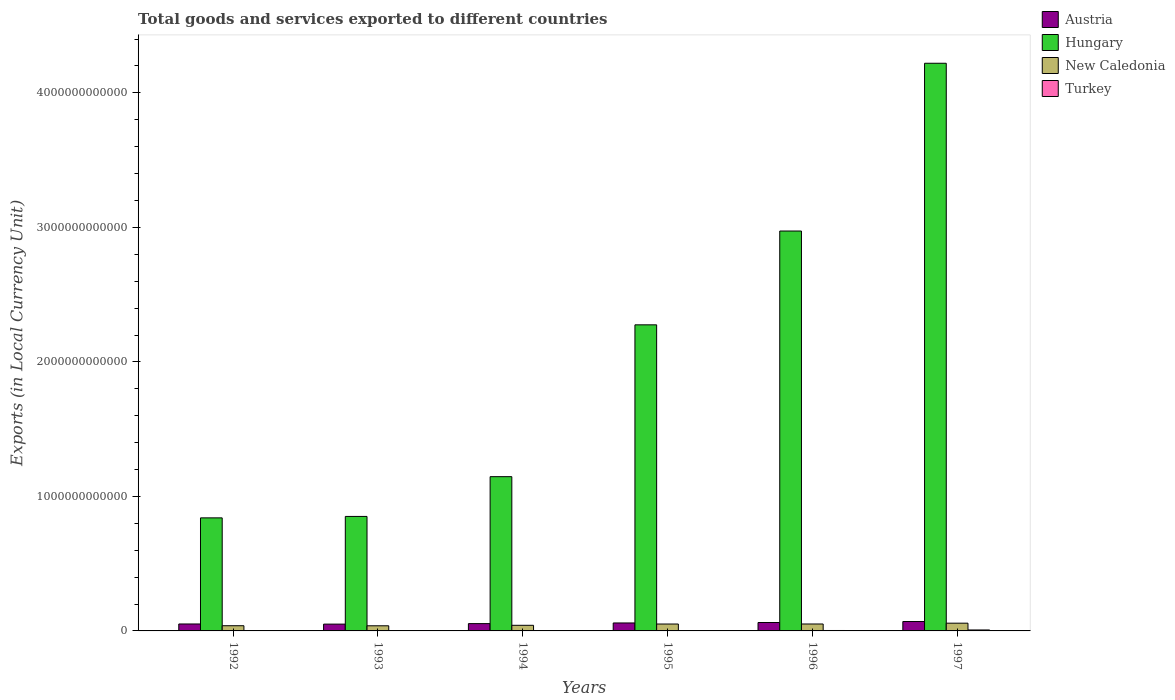How many groups of bars are there?
Give a very brief answer. 6. Are the number of bars per tick equal to the number of legend labels?
Provide a short and direct response. Yes. How many bars are there on the 1st tick from the right?
Your response must be concise. 4. In how many cases, is the number of bars for a given year not equal to the number of legend labels?
Give a very brief answer. 0. What is the Amount of goods and services exports in Austria in 1994?
Your answer should be compact. 5.43e+1. Across all years, what is the maximum Amount of goods and services exports in Hungary?
Your answer should be very brief. 4.22e+12. Across all years, what is the minimum Amount of goods and services exports in Hungary?
Offer a terse response. 8.41e+11. In which year was the Amount of goods and services exports in Turkey maximum?
Give a very brief answer. 1997. What is the total Amount of goods and services exports in Turkey in the graph?
Make the answer very short. 1.31e+1. What is the difference between the Amount of goods and services exports in New Caledonia in 1993 and that in 1994?
Make the answer very short. -3.61e+09. What is the difference between the Amount of goods and services exports in Turkey in 1993 and the Amount of goods and services exports in New Caledonia in 1995?
Give a very brief answer. -5.10e+1. What is the average Amount of goods and services exports in Turkey per year?
Offer a very short reply. 2.18e+09. In the year 1994, what is the difference between the Amount of goods and services exports in Austria and Amount of goods and services exports in Hungary?
Keep it short and to the point. -1.09e+12. What is the ratio of the Amount of goods and services exports in Turkey in 1993 to that in 1996?
Provide a succinct answer. 0.09. Is the Amount of goods and services exports in Austria in 1992 less than that in 1996?
Your answer should be compact. Yes. What is the difference between the highest and the second highest Amount of goods and services exports in New Caledonia?
Make the answer very short. 6.12e+09. What is the difference between the highest and the lowest Amount of goods and services exports in New Caledonia?
Provide a succinct answer. 1.95e+1. Is it the case that in every year, the sum of the Amount of goods and services exports in New Caledonia and Amount of goods and services exports in Turkey is greater than the sum of Amount of goods and services exports in Austria and Amount of goods and services exports in Hungary?
Offer a terse response. No. What does the 1st bar from the left in 1995 represents?
Provide a succinct answer. Austria. What does the 4th bar from the right in 1994 represents?
Make the answer very short. Austria. Is it the case that in every year, the sum of the Amount of goods and services exports in Hungary and Amount of goods and services exports in New Caledonia is greater than the Amount of goods and services exports in Turkey?
Give a very brief answer. Yes. How many bars are there?
Your answer should be compact. 24. How many years are there in the graph?
Give a very brief answer. 6. What is the difference between two consecutive major ticks on the Y-axis?
Your answer should be compact. 1.00e+12. Are the values on the major ticks of Y-axis written in scientific E-notation?
Give a very brief answer. No. Where does the legend appear in the graph?
Ensure brevity in your answer.  Top right. How many legend labels are there?
Your answer should be compact. 4. How are the legend labels stacked?
Provide a short and direct response. Vertical. What is the title of the graph?
Give a very brief answer. Total goods and services exported to different countries. Does "Romania" appear as one of the legend labels in the graph?
Provide a short and direct response. No. What is the label or title of the Y-axis?
Ensure brevity in your answer.  Exports (in Local Currency Unit). What is the Exports (in Local Currency Unit) in Austria in 1992?
Your answer should be compact. 5.17e+1. What is the Exports (in Local Currency Unit) of Hungary in 1992?
Provide a short and direct response. 8.41e+11. What is the Exports (in Local Currency Unit) of New Caledonia in 1992?
Offer a terse response. 3.86e+1. What is the Exports (in Local Currency Unit) in Turkey in 1992?
Your answer should be compact. 1.57e+08. What is the Exports (in Local Currency Unit) in Austria in 1993?
Provide a short and direct response. 5.06e+1. What is the Exports (in Local Currency Unit) in Hungary in 1993?
Offer a very short reply. 8.51e+11. What is the Exports (in Local Currency Unit) in New Caledonia in 1993?
Give a very brief answer. 3.81e+1. What is the Exports (in Local Currency Unit) in Turkey in 1993?
Provide a short and direct response. 2.71e+08. What is the Exports (in Local Currency Unit) in Austria in 1994?
Your answer should be compact. 5.43e+1. What is the Exports (in Local Currency Unit) of Hungary in 1994?
Offer a terse response. 1.15e+12. What is the Exports (in Local Currency Unit) in New Caledonia in 1994?
Give a very brief answer. 4.17e+1. What is the Exports (in Local Currency Unit) of Turkey in 1994?
Ensure brevity in your answer.  8.26e+08. What is the Exports (in Local Currency Unit) in Austria in 1995?
Ensure brevity in your answer.  5.92e+1. What is the Exports (in Local Currency Unit) in Hungary in 1995?
Provide a succinct answer. 2.28e+12. What is the Exports (in Local Currency Unit) in New Caledonia in 1995?
Provide a short and direct response. 5.13e+1. What is the Exports (in Local Currency Unit) of Turkey in 1995?
Make the answer very short. 1.54e+09. What is the Exports (in Local Currency Unit) of Austria in 1996?
Offer a very short reply. 6.25e+1. What is the Exports (in Local Currency Unit) of Hungary in 1996?
Provide a succinct answer. 2.97e+12. What is the Exports (in Local Currency Unit) of New Caledonia in 1996?
Your answer should be compact. 5.15e+1. What is the Exports (in Local Currency Unit) in Turkey in 1996?
Make the answer very short. 3.18e+09. What is the Exports (in Local Currency Unit) in Austria in 1997?
Provide a succinct answer. 6.99e+1. What is the Exports (in Local Currency Unit) of Hungary in 1997?
Make the answer very short. 4.22e+12. What is the Exports (in Local Currency Unit) of New Caledonia in 1997?
Offer a very short reply. 5.76e+1. What is the Exports (in Local Currency Unit) in Turkey in 1997?
Offer a terse response. 7.09e+09. Across all years, what is the maximum Exports (in Local Currency Unit) in Austria?
Offer a very short reply. 6.99e+1. Across all years, what is the maximum Exports (in Local Currency Unit) in Hungary?
Ensure brevity in your answer.  4.22e+12. Across all years, what is the maximum Exports (in Local Currency Unit) of New Caledonia?
Make the answer very short. 5.76e+1. Across all years, what is the maximum Exports (in Local Currency Unit) in Turkey?
Make the answer very short. 7.09e+09. Across all years, what is the minimum Exports (in Local Currency Unit) in Austria?
Your answer should be very brief. 5.06e+1. Across all years, what is the minimum Exports (in Local Currency Unit) of Hungary?
Make the answer very short. 8.41e+11. Across all years, what is the minimum Exports (in Local Currency Unit) in New Caledonia?
Provide a succinct answer. 3.81e+1. Across all years, what is the minimum Exports (in Local Currency Unit) of Turkey?
Offer a terse response. 1.57e+08. What is the total Exports (in Local Currency Unit) of Austria in the graph?
Give a very brief answer. 3.48e+11. What is the total Exports (in Local Currency Unit) of Hungary in the graph?
Offer a terse response. 1.23e+13. What is the total Exports (in Local Currency Unit) of New Caledonia in the graph?
Your response must be concise. 2.79e+11. What is the total Exports (in Local Currency Unit) of Turkey in the graph?
Your response must be concise. 1.31e+1. What is the difference between the Exports (in Local Currency Unit) in Austria in 1992 and that in 1993?
Your response must be concise. 1.02e+09. What is the difference between the Exports (in Local Currency Unit) in Hungary in 1992 and that in 1993?
Your response must be concise. -1.06e+1. What is the difference between the Exports (in Local Currency Unit) of New Caledonia in 1992 and that in 1993?
Your answer should be compact. 4.84e+08. What is the difference between the Exports (in Local Currency Unit) in Turkey in 1992 and that in 1993?
Your response must be concise. -1.14e+08. What is the difference between the Exports (in Local Currency Unit) of Austria in 1992 and that in 1994?
Your response must be concise. -2.68e+09. What is the difference between the Exports (in Local Currency Unit) of Hungary in 1992 and that in 1994?
Provide a short and direct response. -3.06e+11. What is the difference between the Exports (in Local Currency Unit) of New Caledonia in 1992 and that in 1994?
Your answer should be very brief. -3.12e+09. What is the difference between the Exports (in Local Currency Unit) of Turkey in 1992 and that in 1994?
Provide a succinct answer. -6.69e+08. What is the difference between the Exports (in Local Currency Unit) in Austria in 1992 and that in 1995?
Keep it short and to the point. -7.57e+09. What is the difference between the Exports (in Local Currency Unit) of Hungary in 1992 and that in 1995?
Your response must be concise. -1.44e+12. What is the difference between the Exports (in Local Currency Unit) in New Caledonia in 1992 and that in 1995?
Provide a succinct answer. -1.27e+1. What is the difference between the Exports (in Local Currency Unit) of Turkey in 1992 and that in 1995?
Make the answer very short. -1.39e+09. What is the difference between the Exports (in Local Currency Unit) of Austria in 1992 and that in 1996?
Your answer should be compact. -1.09e+1. What is the difference between the Exports (in Local Currency Unit) in Hungary in 1992 and that in 1996?
Provide a short and direct response. -2.13e+12. What is the difference between the Exports (in Local Currency Unit) in New Caledonia in 1992 and that in 1996?
Your response must be concise. -1.29e+1. What is the difference between the Exports (in Local Currency Unit) in Turkey in 1992 and that in 1996?
Make the answer very short. -3.02e+09. What is the difference between the Exports (in Local Currency Unit) in Austria in 1992 and that in 1997?
Ensure brevity in your answer.  -1.82e+1. What is the difference between the Exports (in Local Currency Unit) in Hungary in 1992 and that in 1997?
Ensure brevity in your answer.  -3.38e+12. What is the difference between the Exports (in Local Currency Unit) of New Caledonia in 1992 and that in 1997?
Your response must be concise. -1.90e+1. What is the difference between the Exports (in Local Currency Unit) in Turkey in 1992 and that in 1997?
Keep it short and to the point. -6.93e+09. What is the difference between the Exports (in Local Currency Unit) in Austria in 1993 and that in 1994?
Your answer should be very brief. -3.70e+09. What is the difference between the Exports (in Local Currency Unit) of Hungary in 1993 and that in 1994?
Your response must be concise. -2.96e+11. What is the difference between the Exports (in Local Currency Unit) of New Caledonia in 1993 and that in 1994?
Your response must be concise. -3.61e+09. What is the difference between the Exports (in Local Currency Unit) in Turkey in 1993 and that in 1994?
Provide a succinct answer. -5.55e+08. What is the difference between the Exports (in Local Currency Unit) of Austria in 1993 and that in 1995?
Ensure brevity in your answer.  -8.59e+09. What is the difference between the Exports (in Local Currency Unit) of Hungary in 1993 and that in 1995?
Your answer should be compact. -1.42e+12. What is the difference between the Exports (in Local Currency Unit) in New Caledonia in 1993 and that in 1995?
Give a very brief answer. -1.31e+1. What is the difference between the Exports (in Local Currency Unit) of Turkey in 1993 and that in 1995?
Offer a terse response. -1.27e+09. What is the difference between the Exports (in Local Currency Unit) in Austria in 1993 and that in 1996?
Keep it short and to the point. -1.19e+1. What is the difference between the Exports (in Local Currency Unit) in Hungary in 1993 and that in 1996?
Keep it short and to the point. -2.12e+12. What is the difference between the Exports (in Local Currency Unit) of New Caledonia in 1993 and that in 1996?
Your response must be concise. -1.34e+1. What is the difference between the Exports (in Local Currency Unit) in Turkey in 1993 and that in 1996?
Offer a very short reply. -2.91e+09. What is the difference between the Exports (in Local Currency Unit) of Austria in 1993 and that in 1997?
Offer a terse response. -1.92e+1. What is the difference between the Exports (in Local Currency Unit) in Hungary in 1993 and that in 1997?
Offer a very short reply. -3.37e+12. What is the difference between the Exports (in Local Currency Unit) in New Caledonia in 1993 and that in 1997?
Keep it short and to the point. -1.95e+1. What is the difference between the Exports (in Local Currency Unit) of Turkey in 1993 and that in 1997?
Your answer should be very brief. -6.82e+09. What is the difference between the Exports (in Local Currency Unit) in Austria in 1994 and that in 1995?
Give a very brief answer. -4.89e+09. What is the difference between the Exports (in Local Currency Unit) in Hungary in 1994 and that in 1995?
Your answer should be very brief. -1.13e+12. What is the difference between the Exports (in Local Currency Unit) in New Caledonia in 1994 and that in 1995?
Give a very brief answer. -9.54e+09. What is the difference between the Exports (in Local Currency Unit) in Turkey in 1994 and that in 1995?
Ensure brevity in your answer.  -7.18e+08. What is the difference between the Exports (in Local Currency Unit) in Austria in 1994 and that in 1996?
Ensure brevity in your answer.  -8.19e+09. What is the difference between the Exports (in Local Currency Unit) of Hungary in 1994 and that in 1996?
Keep it short and to the point. -1.83e+12. What is the difference between the Exports (in Local Currency Unit) in New Caledonia in 1994 and that in 1996?
Your answer should be very brief. -9.78e+09. What is the difference between the Exports (in Local Currency Unit) of Turkey in 1994 and that in 1996?
Keep it short and to the point. -2.36e+09. What is the difference between the Exports (in Local Currency Unit) of Austria in 1994 and that in 1997?
Provide a short and direct response. -1.55e+1. What is the difference between the Exports (in Local Currency Unit) of Hungary in 1994 and that in 1997?
Give a very brief answer. -3.07e+12. What is the difference between the Exports (in Local Currency Unit) in New Caledonia in 1994 and that in 1997?
Make the answer very short. -1.59e+1. What is the difference between the Exports (in Local Currency Unit) of Turkey in 1994 and that in 1997?
Provide a succinct answer. -6.26e+09. What is the difference between the Exports (in Local Currency Unit) in Austria in 1995 and that in 1996?
Your answer should be compact. -3.30e+09. What is the difference between the Exports (in Local Currency Unit) of Hungary in 1995 and that in 1996?
Give a very brief answer. -6.97e+11. What is the difference between the Exports (in Local Currency Unit) of New Caledonia in 1995 and that in 1996?
Provide a short and direct response. -2.33e+08. What is the difference between the Exports (in Local Currency Unit) in Turkey in 1995 and that in 1996?
Offer a terse response. -1.64e+09. What is the difference between the Exports (in Local Currency Unit) in Austria in 1995 and that in 1997?
Give a very brief answer. -1.07e+1. What is the difference between the Exports (in Local Currency Unit) in Hungary in 1995 and that in 1997?
Keep it short and to the point. -1.94e+12. What is the difference between the Exports (in Local Currency Unit) in New Caledonia in 1995 and that in 1997?
Your response must be concise. -6.35e+09. What is the difference between the Exports (in Local Currency Unit) of Turkey in 1995 and that in 1997?
Ensure brevity in your answer.  -5.54e+09. What is the difference between the Exports (in Local Currency Unit) of Austria in 1996 and that in 1997?
Your answer should be very brief. -7.36e+09. What is the difference between the Exports (in Local Currency Unit) in Hungary in 1996 and that in 1997?
Offer a terse response. -1.25e+12. What is the difference between the Exports (in Local Currency Unit) of New Caledonia in 1996 and that in 1997?
Keep it short and to the point. -6.12e+09. What is the difference between the Exports (in Local Currency Unit) in Turkey in 1996 and that in 1997?
Provide a succinct answer. -3.91e+09. What is the difference between the Exports (in Local Currency Unit) in Austria in 1992 and the Exports (in Local Currency Unit) in Hungary in 1993?
Give a very brief answer. -8.00e+11. What is the difference between the Exports (in Local Currency Unit) in Austria in 1992 and the Exports (in Local Currency Unit) in New Caledonia in 1993?
Give a very brief answer. 1.36e+1. What is the difference between the Exports (in Local Currency Unit) in Austria in 1992 and the Exports (in Local Currency Unit) in Turkey in 1993?
Provide a succinct answer. 5.14e+1. What is the difference between the Exports (in Local Currency Unit) of Hungary in 1992 and the Exports (in Local Currency Unit) of New Caledonia in 1993?
Offer a very short reply. 8.02e+11. What is the difference between the Exports (in Local Currency Unit) in Hungary in 1992 and the Exports (in Local Currency Unit) in Turkey in 1993?
Give a very brief answer. 8.40e+11. What is the difference between the Exports (in Local Currency Unit) of New Caledonia in 1992 and the Exports (in Local Currency Unit) of Turkey in 1993?
Make the answer very short. 3.83e+1. What is the difference between the Exports (in Local Currency Unit) of Austria in 1992 and the Exports (in Local Currency Unit) of Hungary in 1994?
Offer a terse response. -1.10e+12. What is the difference between the Exports (in Local Currency Unit) in Austria in 1992 and the Exports (in Local Currency Unit) in New Caledonia in 1994?
Ensure brevity in your answer.  9.95e+09. What is the difference between the Exports (in Local Currency Unit) in Austria in 1992 and the Exports (in Local Currency Unit) in Turkey in 1994?
Offer a very short reply. 5.08e+1. What is the difference between the Exports (in Local Currency Unit) of Hungary in 1992 and the Exports (in Local Currency Unit) of New Caledonia in 1994?
Your response must be concise. 7.99e+11. What is the difference between the Exports (in Local Currency Unit) in Hungary in 1992 and the Exports (in Local Currency Unit) in Turkey in 1994?
Give a very brief answer. 8.40e+11. What is the difference between the Exports (in Local Currency Unit) in New Caledonia in 1992 and the Exports (in Local Currency Unit) in Turkey in 1994?
Ensure brevity in your answer.  3.78e+1. What is the difference between the Exports (in Local Currency Unit) in Austria in 1992 and the Exports (in Local Currency Unit) in Hungary in 1995?
Give a very brief answer. -2.22e+12. What is the difference between the Exports (in Local Currency Unit) of Austria in 1992 and the Exports (in Local Currency Unit) of New Caledonia in 1995?
Keep it short and to the point. 4.01e+08. What is the difference between the Exports (in Local Currency Unit) of Austria in 1992 and the Exports (in Local Currency Unit) of Turkey in 1995?
Offer a very short reply. 5.01e+1. What is the difference between the Exports (in Local Currency Unit) of Hungary in 1992 and the Exports (in Local Currency Unit) of New Caledonia in 1995?
Provide a short and direct response. 7.89e+11. What is the difference between the Exports (in Local Currency Unit) in Hungary in 1992 and the Exports (in Local Currency Unit) in Turkey in 1995?
Provide a succinct answer. 8.39e+11. What is the difference between the Exports (in Local Currency Unit) in New Caledonia in 1992 and the Exports (in Local Currency Unit) in Turkey in 1995?
Give a very brief answer. 3.70e+1. What is the difference between the Exports (in Local Currency Unit) in Austria in 1992 and the Exports (in Local Currency Unit) in Hungary in 1996?
Offer a very short reply. -2.92e+12. What is the difference between the Exports (in Local Currency Unit) in Austria in 1992 and the Exports (in Local Currency Unit) in New Caledonia in 1996?
Your answer should be very brief. 1.68e+08. What is the difference between the Exports (in Local Currency Unit) of Austria in 1992 and the Exports (in Local Currency Unit) of Turkey in 1996?
Your response must be concise. 4.85e+1. What is the difference between the Exports (in Local Currency Unit) in Hungary in 1992 and the Exports (in Local Currency Unit) in New Caledonia in 1996?
Your answer should be very brief. 7.89e+11. What is the difference between the Exports (in Local Currency Unit) in Hungary in 1992 and the Exports (in Local Currency Unit) in Turkey in 1996?
Provide a short and direct response. 8.37e+11. What is the difference between the Exports (in Local Currency Unit) of New Caledonia in 1992 and the Exports (in Local Currency Unit) of Turkey in 1996?
Keep it short and to the point. 3.54e+1. What is the difference between the Exports (in Local Currency Unit) of Austria in 1992 and the Exports (in Local Currency Unit) of Hungary in 1997?
Offer a terse response. -4.17e+12. What is the difference between the Exports (in Local Currency Unit) in Austria in 1992 and the Exports (in Local Currency Unit) in New Caledonia in 1997?
Your answer should be very brief. -5.95e+09. What is the difference between the Exports (in Local Currency Unit) in Austria in 1992 and the Exports (in Local Currency Unit) in Turkey in 1997?
Offer a very short reply. 4.46e+1. What is the difference between the Exports (in Local Currency Unit) in Hungary in 1992 and the Exports (in Local Currency Unit) in New Caledonia in 1997?
Provide a short and direct response. 7.83e+11. What is the difference between the Exports (in Local Currency Unit) of Hungary in 1992 and the Exports (in Local Currency Unit) of Turkey in 1997?
Provide a short and direct response. 8.33e+11. What is the difference between the Exports (in Local Currency Unit) of New Caledonia in 1992 and the Exports (in Local Currency Unit) of Turkey in 1997?
Give a very brief answer. 3.15e+1. What is the difference between the Exports (in Local Currency Unit) of Austria in 1993 and the Exports (in Local Currency Unit) of Hungary in 1994?
Provide a short and direct response. -1.10e+12. What is the difference between the Exports (in Local Currency Unit) of Austria in 1993 and the Exports (in Local Currency Unit) of New Caledonia in 1994?
Ensure brevity in your answer.  8.93e+09. What is the difference between the Exports (in Local Currency Unit) in Austria in 1993 and the Exports (in Local Currency Unit) in Turkey in 1994?
Your answer should be compact. 4.98e+1. What is the difference between the Exports (in Local Currency Unit) of Hungary in 1993 and the Exports (in Local Currency Unit) of New Caledonia in 1994?
Ensure brevity in your answer.  8.09e+11. What is the difference between the Exports (in Local Currency Unit) in Hungary in 1993 and the Exports (in Local Currency Unit) in Turkey in 1994?
Make the answer very short. 8.50e+11. What is the difference between the Exports (in Local Currency Unit) in New Caledonia in 1993 and the Exports (in Local Currency Unit) in Turkey in 1994?
Your answer should be compact. 3.73e+1. What is the difference between the Exports (in Local Currency Unit) in Austria in 1993 and the Exports (in Local Currency Unit) in Hungary in 1995?
Your answer should be very brief. -2.23e+12. What is the difference between the Exports (in Local Currency Unit) in Austria in 1993 and the Exports (in Local Currency Unit) in New Caledonia in 1995?
Your answer should be compact. -6.17e+08. What is the difference between the Exports (in Local Currency Unit) in Austria in 1993 and the Exports (in Local Currency Unit) in Turkey in 1995?
Your answer should be compact. 4.91e+1. What is the difference between the Exports (in Local Currency Unit) in Hungary in 1993 and the Exports (in Local Currency Unit) in New Caledonia in 1995?
Ensure brevity in your answer.  8.00e+11. What is the difference between the Exports (in Local Currency Unit) of Hungary in 1993 and the Exports (in Local Currency Unit) of Turkey in 1995?
Offer a very short reply. 8.50e+11. What is the difference between the Exports (in Local Currency Unit) in New Caledonia in 1993 and the Exports (in Local Currency Unit) in Turkey in 1995?
Ensure brevity in your answer.  3.66e+1. What is the difference between the Exports (in Local Currency Unit) in Austria in 1993 and the Exports (in Local Currency Unit) in Hungary in 1996?
Your answer should be very brief. -2.92e+12. What is the difference between the Exports (in Local Currency Unit) of Austria in 1993 and the Exports (in Local Currency Unit) of New Caledonia in 1996?
Ensure brevity in your answer.  -8.50e+08. What is the difference between the Exports (in Local Currency Unit) in Austria in 1993 and the Exports (in Local Currency Unit) in Turkey in 1996?
Offer a very short reply. 4.75e+1. What is the difference between the Exports (in Local Currency Unit) in Hungary in 1993 and the Exports (in Local Currency Unit) in New Caledonia in 1996?
Make the answer very short. 8.00e+11. What is the difference between the Exports (in Local Currency Unit) of Hungary in 1993 and the Exports (in Local Currency Unit) of Turkey in 1996?
Your answer should be very brief. 8.48e+11. What is the difference between the Exports (in Local Currency Unit) of New Caledonia in 1993 and the Exports (in Local Currency Unit) of Turkey in 1996?
Ensure brevity in your answer.  3.49e+1. What is the difference between the Exports (in Local Currency Unit) in Austria in 1993 and the Exports (in Local Currency Unit) in Hungary in 1997?
Your answer should be compact. -4.17e+12. What is the difference between the Exports (in Local Currency Unit) of Austria in 1993 and the Exports (in Local Currency Unit) of New Caledonia in 1997?
Your response must be concise. -6.97e+09. What is the difference between the Exports (in Local Currency Unit) of Austria in 1993 and the Exports (in Local Currency Unit) of Turkey in 1997?
Keep it short and to the point. 4.35e+1. What is the difference between the Exports (in Local Currency Unit) in Hungary in 1993 and the Exports (in Local Currency Unit) in New Caledonia in 1997?
Offer a terse response. 7.94e+11. What is the difference between the Exports (in Local Currency Unit) in Hungary in 1993 and the Exports (in Local Currency Unit) in Turkey in 1997?
Provide a short and direct response. 8.44e+11. What is the difference between the Exports (in Local Currency Unit) of New Caledonia in 1993 and the Exports (in Local Currency Unit) of Turkey in 1997?
Provide a succinct answer. 3.10e+1. What is the difference between the Exports (in Local Currency Unit) in Austria in 1994 and the Exports (in Local Currency Unit) in Hungary in 1995?
Ensure brevity in your answer.  -2.22e+12. What is the difference between the Exports (in Local Currency Unit) of Austria in 1994 and the Exports (in Local Currency Unit) of New Caledonia in 1995?
Your answer should be very brief. 3.08e+09. What is the difference between the Exports (in Local Currency Unit) in Austria in 1994 and the Exports (in Local Currency Unit) in Turkey in 1995?
Provide a short and direct response. 5.28e+1. What is the difference between the Exports (in Local Currency Unit) of Hungary in 1994 and the Exports (in Local Currency Unit) of New Caledonia in 1995?
Provide a short and direct response. 1.10e+12. What is the difference between the Exports (in Local Currency Unit) of Hungary in 1994 and the Exports (in Local Currency Unit) of Turkey in 1995?
Ensure brevity in your answer.  1.15e+12. What is the difference between the Exports (in Local Currency Unit) in New Caledonia in 1994 and the Exports (in Local Currency Unit) in Turkey in 1995?
Provide a succinct answer. 4.02e+1. What is the difference between the Exports (in Local Currency Unit) of Austria in 1994 and the Exports (in Local Currency Unit) of Hungary in 1996?
Your answer should be compact. -2.92e+12. What is the difference between the Exports (in Local Currency Unit) of Austria in 1994 and the Exports (in Local Currency Unit) of New Caledonia in 1996?
Provide a succinct answer. 2.85e+09. What is the difference between the Exports (in Local Currency Unit) in Austria in 1994 and the Exports (in Local Currency Unit) in Turkey in 1996?
Offer a terse response. 5.12e+1. What is the difference between the Exports (in Local Currency Unit) in Hungary in 1994 and the Exports (in Local Currency Unit) in New Caledonia in 1996?
Keep it short and to the point. 1.10e+12. What is the difference between the Exports (in Local Currency Unit) in Hungary in 1994 and the Exports (in Local Currency Unit) in Turkey in 1996?
Give a very brief answer. 1.14e+12. What is the difference between the Exports (in Local Currency Unit) of New Caledonia in 1994 and the Exports (in Local Currency Unit) of Turkey in 1996?
Ensure brevity in your answer.  3.85e+1. What is the difference between the Exports (in Local Currency Unit) of Austria in 1994 and the Exports (in Local Currency Unit) of Hungary in 1997?
Offer a very short reply. -4.17e+12. What is the difference between the Exports (in Local Currency Unit) of Austria in 1994 and the Exports (in Local Currency Unit) of New Caledonia in 1997?
Ensure brevity in your answer.  -3.27e+09. What is the difference between the Exports (in Local Currency Unit) of Austria in 1994 and the Exports (in Local Currency Unit) of Turkey in 1997?
Provide a succinct answer. 4.72e+1. What is the difference between the Exports (in Local Currency Unit) in Hungary in 1994 and the Exports (in Local Currency Unit) in New Caledonia in 1997?
Ensure brevity in your answer.  1.09e+12. What is the difference between the Exports (in Local Currency Unit) in Hungary in 1994 and the Exports (in Local Currency Unit) in Turkey in 1997?
Provide a short and direct response. 1.14e+12. What is the difference between the Exports (in Local Currency Unit) of New Caledonia in 1994 and the Exports (in Local Currency Unit) of Turkey in 1997?
Your answer should be very brief. 3.46e+1. What is the difference between the Exports (in Local Currency Unit) of Austria in 1995 and the Exports (in Local Currency Unit) of Hungary in 1996?
Ensure brevity in your answer.  -2.91e+12. What is the difference between the Exports (in Local Currency Unit) of Austria in 1995 and the Exports (in Local Currency Unit) of New Caledonia in 1996?
Give a very brief answer. 7.74e+09. What is the difference between the Exports (in Local Currency Unit) of Austria in 1995 and the Exports (in Local Currency Unit) of Turkey in 1996?
Your answer should be very brief. 5.60e+1. What is the difference between the Exports (in Local Currency Unit) of Hungary in 1995 and the Exports (in Local Currency Unit) of New Caledonia in 1996?
Give a very brief answer. 2.22e+12. What is the difference between the Exports (in Local Currency Unit) of Hungary in 1995 and the Exports (in Local Currency Unit) of Turkey in 1996?
Provide a succinct answer. 2.27e+12. What is the difference between the Exports (in Local Currency Unit) in New Caledonia in 1995 and the Exports (in Local Currency Unit) in Turkey in 1996?
Ensure brevity in your answer.  4.81e+1. What is the difference between the Exports (in Local Currency Unit) of Austria in 1995 and the Exports (in Local Currency Unit) of Hungary in 1997?
Provide a short and direct response. -4.16e+12. What is the difference between the Exports (in Local Currency Unit) of Austria in 1995 and the Exports (in Local Currency Unit) of New Caledonia in 1997?
Your response must be concise. 1.62e+09. What is the difference between the Exports (in Local Currency Unit) of Austria in 1995 and the Exports (in Local Currency Unit) of Turkey in 1997?
Your answer should be very brief. 5.21e+1. What is the difference between the Exports (in Local Currency Unit) of Hungary in 1995 and the Exports (in Local Currency Unit) of New Caledonia in 1997?
Your answer should be very brief. 2.22e+12. What is the difference between the Exports (in Local Currency Unit) of Hungary in 1995 and the Exports (in Local Currency Unit) of Turkey in 1997?
Your response must be concise. 2.27e+12. What is the difference between the Exports (in Local Currency Unit) of New Caledonia in 1995 and the Exports (in Local Currency Unit) of Turkey in 1997?
Offer a very short reply. 4.42e+1. What is the difference between the Exports (in Local Currency Unit) of Austria in 1996 and the Exports (in Local Currency Unit) of Hungary in 1997?
Your answer should be very brief. -4.16e+12. What is the difference between the Exports (in Local Currency Unit) in Austria in 1996 and the Exports (in Local Currency Unit) in New Caledonia in 1997?
Provide a succinct answer. 4.92e+09. What is the difference between the Exports (in Local Currency Unit) in Austria in 1996 and the Exports (in Local Currency Unit) in Turkey in 1997?
Ensure brevity in your answer.  5.54e+1. What is the difference between the Exports (in Local Currency Unit) of Hungary in 1996 and the Exports (in Local Currency Unit) of New Caledonia in 1997?
Your answer should be compact. 2.92e+12. What is the difference between the Exports (in Local Currency Unit) of Hungary in 1996 and the Exports (in Local Currency Unit) of Turkey in 1997?
Offer a terse response. 2.97e+12. What is the difference between the Exports (in Local Currency Unit) in New Caledonia in 1996 and the Exports (in Local Currency Unit) in Turkey in 1997?
Your answer should be compact. 4.44e+1. What is the average Exports (in Local Currency Unit) of Austria per year?
Your answer should be compact. 5.80e+1. What is the average Exports (in Local Currency Unit) in Hungary per year?
Offer a terse response. 2.05e+12. What is the average Exports (in Local Currency Unit) of New Caledonia per year?
Your response must be concise. 4.65e+1. What is the average Exports (in Local Currency Unit) in Turkey per year?
Your answer should be very brief. 2.18e+09. In the year 1992, what is the difference between the Exports (in Local Currency Unit) in Austria and Exports (in Local Currency Unit) in Hungary?
Your answer should be very brief. -7.89e+11. In the year 1992, what is the difference between the Exports (in Local Currency Unit) in Austria and Exports (in Local Currency Unit) in New Caledonia?
Offer a very short reply. 1.31e+1. In the year 1992, what is the difference between the Exports (in Local Currency Unit) of Austria and Exports (in Local Currency Unit) of Turkey?
Your answer should be compact. 5.15e+1. In the year 1992, what is the difference between the Exports (in Local Currency Unit) of Hungary and Exports (in Local Currency Unit) of New Caledonia?
Offer a very short reply. 8.02e+11. In the year 1992, what is the difference between the Exports (in Local Currency Unit) in Hungary and Exports (in Local Currency Unit) in Turkey?
Keep it short and to the point. 8.40e+11. In the year 1992, what is the difference between the Exports (in Local Currency Unit) of New Caledonia and Exports (in Local Currency Unit) of Turkey?
Your answer should be very brief. 3.84e+1. In the year 1993, what is the difference between the Exports (in Local Currency Unit) of Austria and Exports (in Local Currency Unit) of Hungary?
Offer a very short reply. -8.01e+11. In the year 1993, what is the difference between the Exports (in Local Currency Unit) in Austria and Exports (in Local Currency Unit) in New Caledonia?
Provide a succinct answer. 1.25e+1. In the year 1993, what is the difference between the Exports (in Local Currency Unit) in Austria and Exports (in Local Currency Unit) in Turkey?
Ensure brevity in your answer.  5.04e+1. In the year 1993, what is the difference between the Exports (in Local Currency Unit) of Hungary and Exports (in Local Currency Unit) of New Caledonia?
Your answer should be compact. 8.13e+11. In the year 1993, what is the difference between the Exports (in Local Currency Unit) in Hungary and Exports (in Local Currency Unit) in Turkey?
Provide a succinct answer. 8.51e+11. In the year 1993, what is the difference between the Exports (in Local Currency Unit) in New Caledonia and Exports (in Local Currency Unit) in Turkey?
Give a very brief answer. 3.78e+1. In the year 1994, what is the difference between the Exports (in Local Currency Unit) of Austria and Exports (in Local Currency Unit) of Hungary?
Provide a succinct answer. -1.09e+12. In the year 1994, what is the difference between the Exports (in Local Currency Unit) of Austria and Exports (in Local Currency Unit) of New Caledonia?
Your answer should be very brief. 1.26e+1. In the year 1994, what is the difference between the Exports (in Local Currency Unit) of Austria and Exports (in Local Currency Unit) of Turkey?
Provide a succinct answer. 5.35e+1. In the year 1994, what is the difference between the Exports (in Local Currency Unit) in Hungary and Exports (in Local Currency Unit) in New Caledonia?
Keep it short and to the point. 1.11e+12. In the year 1994, what is the difference between the Exports (in Local Currency Unit) of Hungary and Exports (in Local Currency Unit) of Turkey?
Offer a terse response. 1.15e+12. In the year 1994, what is the difference between the Exports (in Local Currency Unit) in New Caledonia and Exports (in Local Currency Unit) in Turkey?
Make the answer very short. 4.09e+1. In the year 1995, what is the difference between the Exports (in Local Currency Unit) in Austria and Exports (in Local Currency Unit) in Hungary?
Offer a very short reply. -2.22e+12. In the year 1995, what is the difference between the Exports (in Local Currency Unit) in Austria and Exports (in Local Currency Unit) in New Caledonia?
Make the answer very short. 7.97e+09. In the year 1995, what is the difference between the Exports (in Local Currency Unit) of Austria and Exports (in Local Currency Unit) of Turkey?
Make the answer very short. 5.77e+1. In the year 1995, what is the difference between the Exports (in Local Currency Unit) in Hungary and Exports (in Local Currency Unit) in New Caledonia?
Keep it short and to the point. 2.22e+12. In the year 1995, what is the difference between the Exports (in Local Currency Unit) of Hungary and Exports (in Local Currency Unit) of Turkey?
Offer a very short reply. 2.27e+12. In the year 1995, what is the difference between the Exports (in Local Currency Unit) of New Caledonia and Exports (in Local Currency Unit) of Turkey?
Ensure brevity in your answer.  4.97e+1. In the year 1996, what is the difference between the Exports (in Local Currency Unit) of Austria and Exports (in Local Currency Unit) of Hungary?
Provide a short and direct response. -2.91e+12. In the year 1996, what is the difference between the Exports (in Local Currency Unit) of Austria and Exports (in Local Currency Unit) of New Caledonia?
Your response must be concise. 1.10e+1. In the year 1996, what is the difference between the Exports (in Local Currency Unit) in Austria and Exports (in Local Currency Unit) in Turkey?
Keep it short and to the point. 5.93e+1. In the year 1996, what is the difference between the Exports (in Local Currency Unit) of Hungary and Exports (in Local Currency Unit) of New Caledonia?
Your answer should be compact. 2.92e+12. In the year 1996, what is the difference between the Exports (in Local Currency Unit) of Hungary and Exports (in Local Currency Unit) of Turkey?
Your answer should be very brief. 2.97e+12. In the year 1996, what is the difference between the Exports (in Local Currency Unit) of New Caledonia and Exports (in Local Currency Unit) of Turkey?
Your response must be concise. 4.83e+1. In the year 1997, what is the difference between the Exports (in Local Currency Unit) in Austria and Exports (in Local Currency Unit) in Hungary?
Provide a succinct answer. -4.15e+12. In the year 1997, what is the difference between the Exports (in Local Currency Unit) in Austria and Exports (in Local Currency Unit) in New Caledonia?
Provide a short and direct response. 1.23e+1. In the year 1997, what is the difference between the Exports (in Local Currency Unit) in Austria and Exports (in Local Currency Unit) in Turkey?
Offer a very short reply. 6.28e+1. In the year 1997, what is the difference between the Exports (in Local Currency Unit) in Hungary and Exports (in Local Currency Unit) in New Caledonia?
Make the answer very short. 4.16e+12. In the year 1997, what is the difference between the Exports (in Local Currency Unit) of Hungary and Exports (in Local Currency Unit) of Turkey?
Keep it short and to the point. 4.21e+12. In the year 1997, what is the difference between the Exports (in Local Currency Unit) of New Caledonia and Exports (in Local Currency Unit) of Turkey?
Make the answer very short. 5.05e+1. What is the ratio of the Exports (in Local Currency Unit) in Austria in 1992 to that in 1993?
Provide a short and direct response. 1.02. What is the ratio of the Exports (in Local Currency Unit) in Hungary in 1992 to that in 1993?
Your answer should be very brief. 0.99. What is the ratio of the Exports (in Local Currency Unit) in New Caledonia in 1992 to that in 1993?
Your answer should be compact. 1.01. What is the ratio of the Exports (in Local Currency Unit) of Turkey in 1992 to that in 1993?
Offer a very short reply. 0.58. What is the ratio of the Exports (in Local Currency Unit) in Austria in 1992 to that in 1994?
Your answer should be very brief. 0.95. What is the ratio of the Exports (in Local Currency Unit) in Hungary in 1992 to that in 1994?
Your answer should be compact. 0.73. What is the ratio of the Exports (in Local Currency Unit) in New Caledonia in 1992 to that in 1994?
Ensure brevity in your answer.  0.93. What is the ratio of the Exports (in Local Currency Unit) of Turkey in 1992 to that in 1994?
Your response must be concise. 0.19. What is the ratio of the Exports (in Local Currency Unit) of Austria in 1992 to that in 1995?
Your response must be concise. 0.87. What is the ratio of the Exports (in Local Currency Unit) in Hungary in 1992 to that in 1995?
Give a very brief answer. 0.37. What is the ratio of the Exports (in Local Currency Unit) in New Caledonia in 1992 to that in 1995?
Your answer should be very brief. 0.75. What is the ratio of the Exports (in Local Currency Unit) in Turkey in 1992 to that in 1995?
Give a very brief answer. 0.1. What is the ratio of the Exports (in Local Currency Unit) of Austria in 1992 to that in 1996?
Give a very brief answer. 0.83. What is the ratio of the Exports (in Local Currency Unit) of Hungary in 1992 to that in 1996?
Make the answer very short. 0.28. What is the ratio of the Exports (in Local Currency Unit) of New Caledonia in 1992 to that in 1996?
Your answer should be compact. 0.75. What is the ratio of the Exports (in Local Currency Unit) of Turkey in 1992 to that in 1996?
Give a very brief answer. 0.05. What is the ratio of the Exports (in Local Currency Unit) in Austria in 1992 to that in 1997?
Provide a succinct answer. 0.74. What is the ratio of the Exports (in Local Currency Unit) of Hungary in 1992 to that in 1997?
Offer a very short reply. 0.2. What is the ratio of the Exports (in Local Currency Unit) of New Caledonia in 1992 to that in 1997?
Ensure brevity in your answer.  0.67. What is the ratio of the Exports (in Local Currency Unit) of Turkey in 1992 to that in 1997?
Offer a terse response. 0.02. What is the ratio of the Exports (in Local Currency Unit) of Austria in 1993 to that in 1994?
Make the answer very short. 0.93. What is the ratio of the Exports (in Local Currency Unit) of Hungary in 1993 to that in 1994?
Provide a succinct answer. 0.74. What is the ratio of the Exports (in Local Currency Unit) of New Caledonia in 1993 to that in 1994?
Your response must be concise. 0.91. What is the ratio of the Exports (in Local Currency Unit) of Turkey in 1993 to that in 1994?
Give a very brief answer. 0.33. What is the ratio of the Exports (in Local Currency Unit) in Austria in 1993 to that in 1995?
Your answer should be compact. 0.85. What is the ratio of the Exports (in Local Currency Unit) in Hungary in 1993 to that in 1995?
Offer a terse response. 0.37. What is the ratio of the Exports (in Local Currency Unit) in New Caledonia in 1993 to that in 1995?
Offer a terse response. 0.74. What is the ratio of the Exports (in Local Currency Unit) of Turkey in 1993 to that in 1995?
Ensure brevity in your answer.  0.18. What is the ratio of the Exports (in Local Currency Unit) of Austria in 1993 to that in 1996?
Your response must be concise. 0.81. What is the ratio of the Exports (in Local Currency Unit) of Hungary in 1993 to that in 1996?
Provide a short and direct response. 0.29. What is the ratio of the Exports (in Local Currency Unit) in New Caledonia in 1993 to that in 1996?
Ensure brevity in your answer.  0.74. What is the ratio of the Exports (in Local Currency Unit) of Turkey in 1993 to that in 1996?
Keep it short and to the point. 0.09. What is the ratio of the Exports (in Local Currency Unit) in Austria in 1993 to that in 1997?
Give a very brief answer. 0.72. What is the ratio of the Exports (in Local Currency Unit) in Hungary in 1993 to that in 1997?
Provide a short and direct response. 0.2. What is the ratio of the Exports (in Local Currency Unit) of New Caledonia in 1993 to that in 1997?
Offer a very short reply. 0.66. What is the ratio of the Exports (in Local Currency Unit) in Turkey in 1993 to that in 1997?
Your answer should be very brief. 0.04. What is the ratio of the Exports (in Local Currency Unit) in Austria in 1994 to that in 1995?
Provide a succinct answer. 0.92. What is the ratio of the Exports (in Local Currency Unit) in Hungary in 1994 to that in 1995?
Offer a very short reply. 0.5. What is the ratio of the Exports (in Local Currency Unit) of New Caledonia in 1994 to that in 1995?
Your response must be concise. 0.81. What is the ratio of the Exports (in Local Currency Unit) in Turkey in 1994 to that in 1995?
Your answer should be very brief. 0.54. What is the ratio of the Exports (in Local Currency Unit) in Austria in 1994 to that in 1996?
Provide a succinct answer. 0.87. What is the ratio of the Exports (in Local Currency Unit) in Hungary in 1994 to that in 1996?
Provide a succinct answer. 0.39. What is the ratio of the Exports (in Local Currency Unit) in New Caledonia in 1994 to that in 1996?
Your response must be concise. 0.81. What is the ratio of the Exports (in Local Currency Unit) in Turkey in 1994 to that in 1996?
Your answer should be very brief. 0.26. What is the ratio of the Exports (in Local Currency Unit) of Austria in 1994 to that in 1997?
Offer a very short reply. 0.78. What is the ratio of the Exports (in Local Currency Unit) in Hungary in 1994 to that in 1997?
Ensure brevity in your answer.  0.27. What is the ratio of the Exports (in Local Currency Unit) in New Caledonia in 1994 to that in 1997?
Your response must be concise. 0.72. What is the ratio of the Exports (in Local Currency Unit) in Turkey in 1994 to that in 1997?
Keep it short and to the point. 0.12. What is the ratio of the Exports (in Local Currency Unit) in Austria in 1995 to that in 1996?
Offer a very short reply. 0.95. What is the ratio of the Exports (in Local Currency Unit) of Hungary in 1995 to that in 1996?
Provide a short and direct response. 0.77. What is the ratio of the Exports (in Local Currency Unit) in New Caledonia in 1995 to that in 1996?
Ensure brevity in your answer.  1. What is the ratio of the Exports (in Local Currency Unit) in Turkey in 1995 to that in 1996?
Your answer should be compact. 0.49. What is the ratio of the Exports (in Local Currency Unit) of Austria in 1995 to that in 1997?
Make the answer very short. 0.85. What is the ratio of the Exports (in Local Currency Unit) of Hungary in 1995 to that in 1997?
Offer a very short reply. 0.54. What is the ratio of the Exports (in Local Currency Unit) in New Caledonia in 1995 to that in 1997?
Offer a terse response. 0.89. What is the ratio of the Exports (in Local Currency Unit) of Turkey in 1995 to that in 1997?
Offer a terse response. 0.22. What is the ratio of the Exports (in Local Currency Unit) in Austria in 1996 to that in 1997?
Provide a succinct answer. 0.89. What is the ratio of the Exports (in Local Currency Unit) in Hungary in 1996 to that in 1997?
Make the answer very short. 0.7. What is the ratio of the Exports (in Local Currency Unit) in New Caledonia in 1996 to that in 1997?
Offer a terse response. 0.89. What is the ratio of the Exports (in Local Currency Unit) in Turkey in 1996 to that in 1997?
Your response must be concise. 0.45. What is the difference between the highest and the second highest Exports (in Local Currency Unit) in Austria?
Offer a terse response. 7.36e+09. What is the difference between the highest and the second highest Exports (in Local Currency Unit) in Hungary?
Give a very brief answer. 1.25e+12. What is the difference between the highest and the second highest Exports (in Local Currency Unit) of New Caledonia?
Your response must be concise. 6.12e+09. What is the difference between the highest and the second highest Exports (in Local Currency Unit) of Turkey?
Make the answer very short. 3.91e+09. What is the difference between the highest and the lowest Exports (in Local Currency Unit) in Austria?
Offer a very short reply. 1.92e+1. What is the difference between the highest and the lowest Exports (in Local Currency Unit) in Hungary?
Provide a short and direct response. 3.38e+12. What is the difference between the highest and the lowest Exports (in Local Currency Unit) of New Caledonia?
Offer a very short reply. 1.95e+1. What is the difference between the highest and the lowest Exports (in Local Currency Unit) in Turkey?
Ensure brevity in your answer.  6.93e+09. 